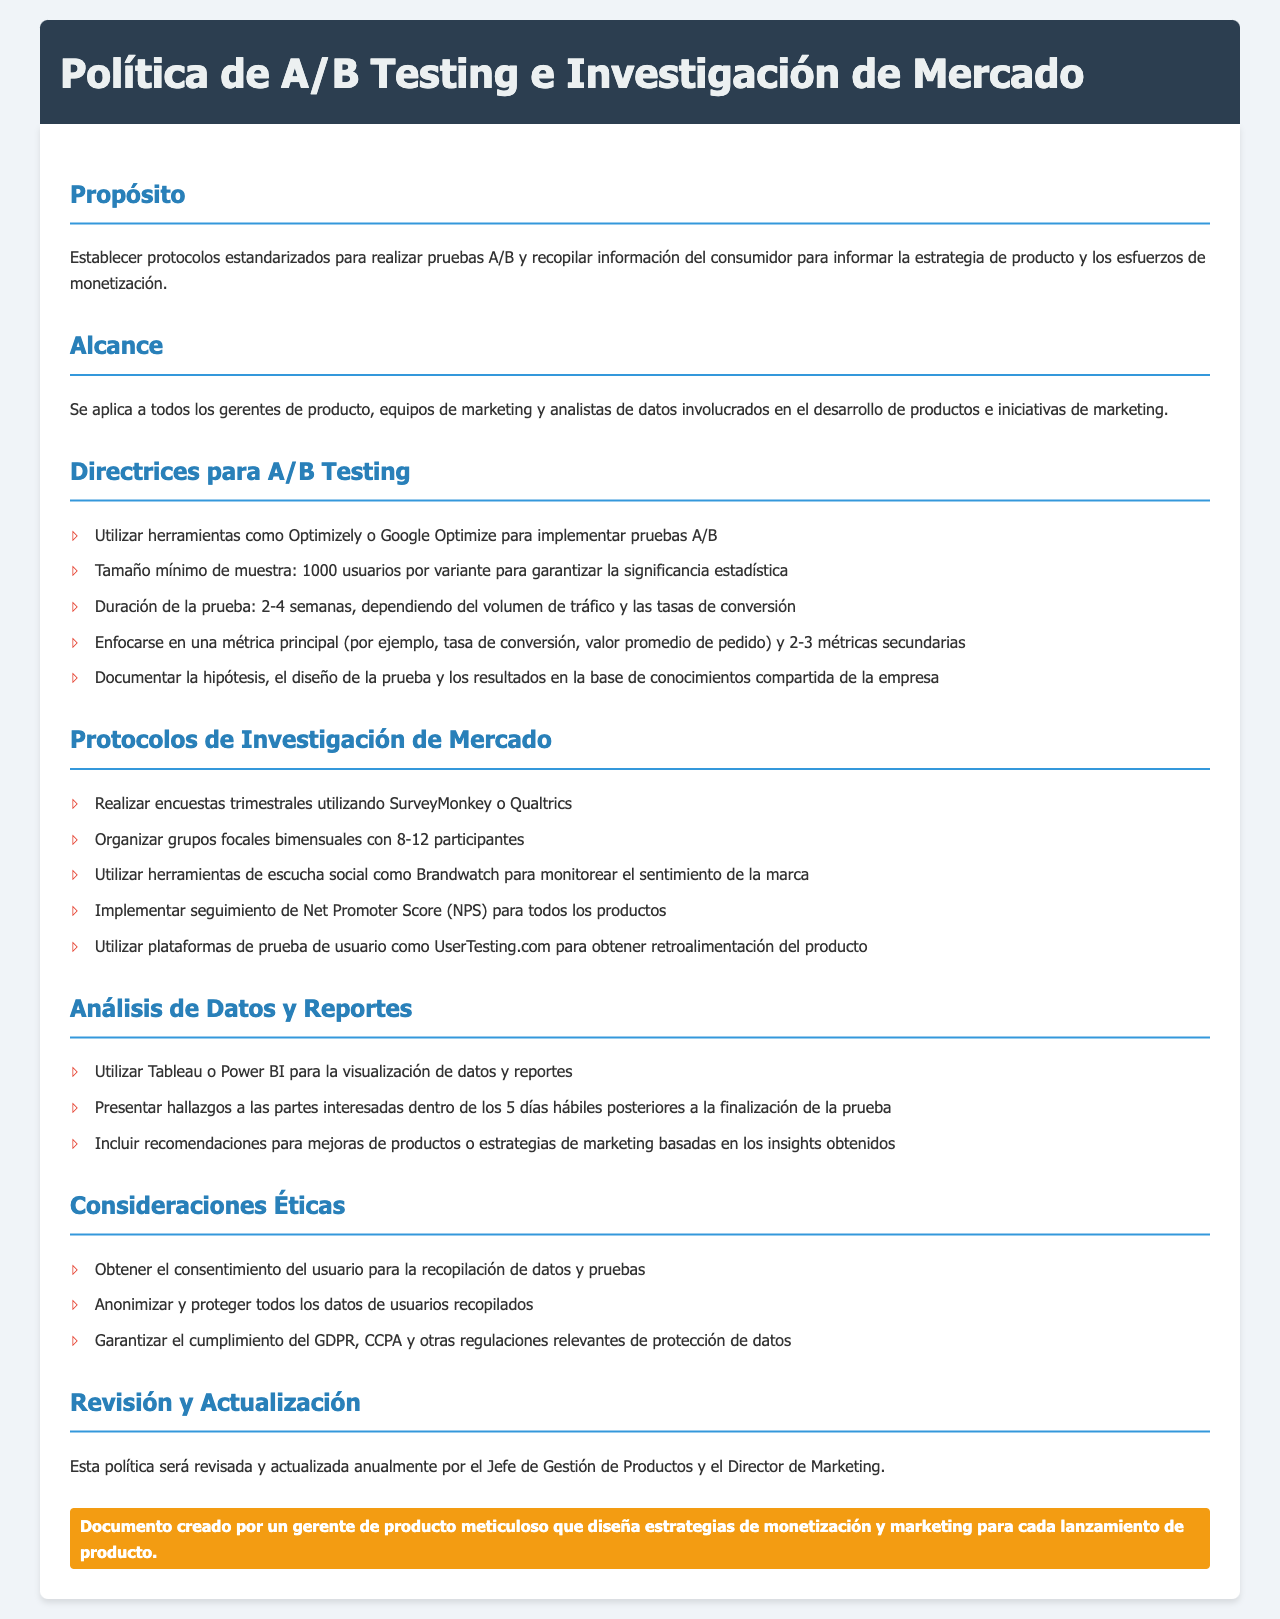¿Cuál es el propósito de la política? El propósito establece protocolos estandarizados para realizar pruebas A/B y recopilar información del consumidor.
Answer: Establecer protocolos estandarizados ¿Qué herramientas se mencionan para implementar pruebas A/B? La sección de directrices para A/B Testing menciona herramientas específicas como Optimizely y Google Optimize.
Answer: Optimizely o Google Optimize ¿Cuál es el tamaño mínimo de muestra requerido? En las directrices se especifica un tamaño mínimo de muestra para pruebas A/B.
Answer: 1000 usuarios ¿Cuántas veces se deben realizar encuestas según los protocolos de investigación de mercado? La sección de protocolos indica que las encuestas deben realizarse trimestralmente.
Answer: Trimestrales ¿Qué herramienta se sugiere para el seguimiento de NPS? Se menciona que se debe implementar el seguimiento de Net Promoter Score (NPS) para todos los productos, pero no se menciona una herramienta específica.
Answer: N/A ¿Cuánto tiempo se debe esperar para presentar hallazgos después de la prueba? La sección sobre análisis de datos y reportes indica un plazo específico para presentar hallazgos.
Answer: 5 días hábiles ¿Cuál es el enfoque ético relacionado con la recopilación de datos? Se establece que se debe obtener el consentimiento del usuario para la recopilación de datos.
Answer: Obtener el consentimiento ¿Cuándo será revisada y actualizada esta política? La sección de revisión y actualización menciona cuándo se llevará a cabo la revisión de la política.
Answer: Anualmente ¿Cuántas métricas secundarias se deben enfocar en las pruebas A/B? En las directrices se recomienda un número específico de métricas secundarias a considerar.
Answer: 2-3 métricas ¿Quién revisará la política anualmente? El documento menciona a dos cargos responsables de la revisión anual de la política.
Answer: Jefe de Gestión de Productos y Director de Marketing 